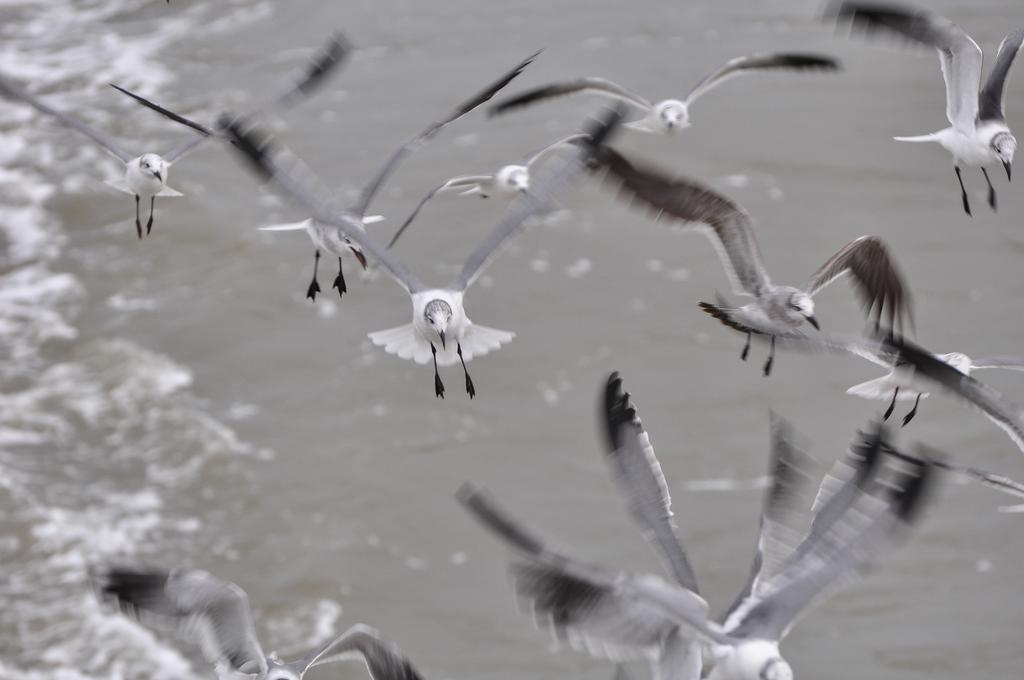What is the color scheme of the image? The image is black and white. What animals can be seen in the image? There are birds flying in the image. What natural element is visible in the background of the image? There is water visible in the background of the image. What time of day is depicted in the image? The image does not provide any information about the time of day, as it is black and white and does not include any clues about the lighting or shadows. 